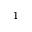Convert formula to latex. <formula><loc_0><loc_0><loc_500><loc_500>1</formula> 